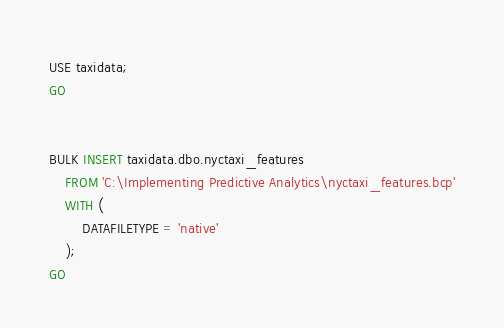<code> <loc_0><loc_0><loc_500><loc_500><_SQL_>USE taxidata;
GO


BULK INSERT taxidata.dbo.nyctaxi_features
    FROM 'C:\Implementing Predictive Analytics\nyctaxi_features.bcp'
    WITH (
        DATAFILETYPE = 'native'
    );
GO</code> 